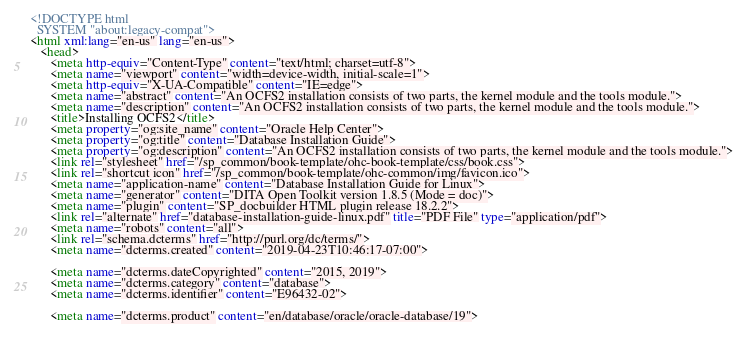Convert code to text. <code><loc_0><loc_0><loc_500><loc_500><_HTML_><!DOCTYPE html
  SYSTEM "about:legacy-compat">
<html xml:lang="en-us" lang="en-us">
   <head>
      <meta http-equiv="Content-Type" content="text/html; charset=utf-8">
      <meta name="viewport" content="width=device-width, initial-scale=1">
      <meta http-equiv="X-UA-Compatible" content="IE=edge">
      <meta name="abstract" content="An OCFS2 installation consists of two parts, the kernel module and the tools module.">
      <meta name="description" content="An OCFS2 installation consists of two parts, the kernel module and the tools module.">
      <title>Installing OCFS2</title>
      <meta property="og:site_name" content="Oracle Help Center">
      <meta property="og:title" content="Database Installation Guide">
      <meta property="og:description" content="An OCFS2 installation consists of two parts, the kernel module and the tools module.">
      <link rel="stylesheet" href="/sp_common/book-template/ohc-book-template/css/book.css">
      <link rel="shortcut icon" href="/sp_common/book-template/ohc-common/img/favicon.ico">
      <meta name="application-name" content="Database Installation Guide for Linux">
      <meta name="generator" content="DITA Open Toolkit version 1.8.5 (Mode = doc)">
      <meta name="plugin" content="SP_docbuilder HTML plugin release 18.2.2">
      <link rel="alternate" href="database-installation-guide-linux.pdf" title="PDF File" type="application/pdf">
      <meta name="robots" content="all">
      <link rel="schema.dcterms" href="http://purl.org/dc/terms/">
      <meta name="dcterms.created" content="2019-04-23T10:46:17-07:00">
      
      <meta name="dcterms.dateCopyrighted" content="2015, 2019">
      <meta name="dcterms.category" content="database">
      <meta name="dcterms.identifier" content="E96432-02">
      
      <meta name="dcterms.product" content="en/database/oracle/oracle-database/19">
      </code> 